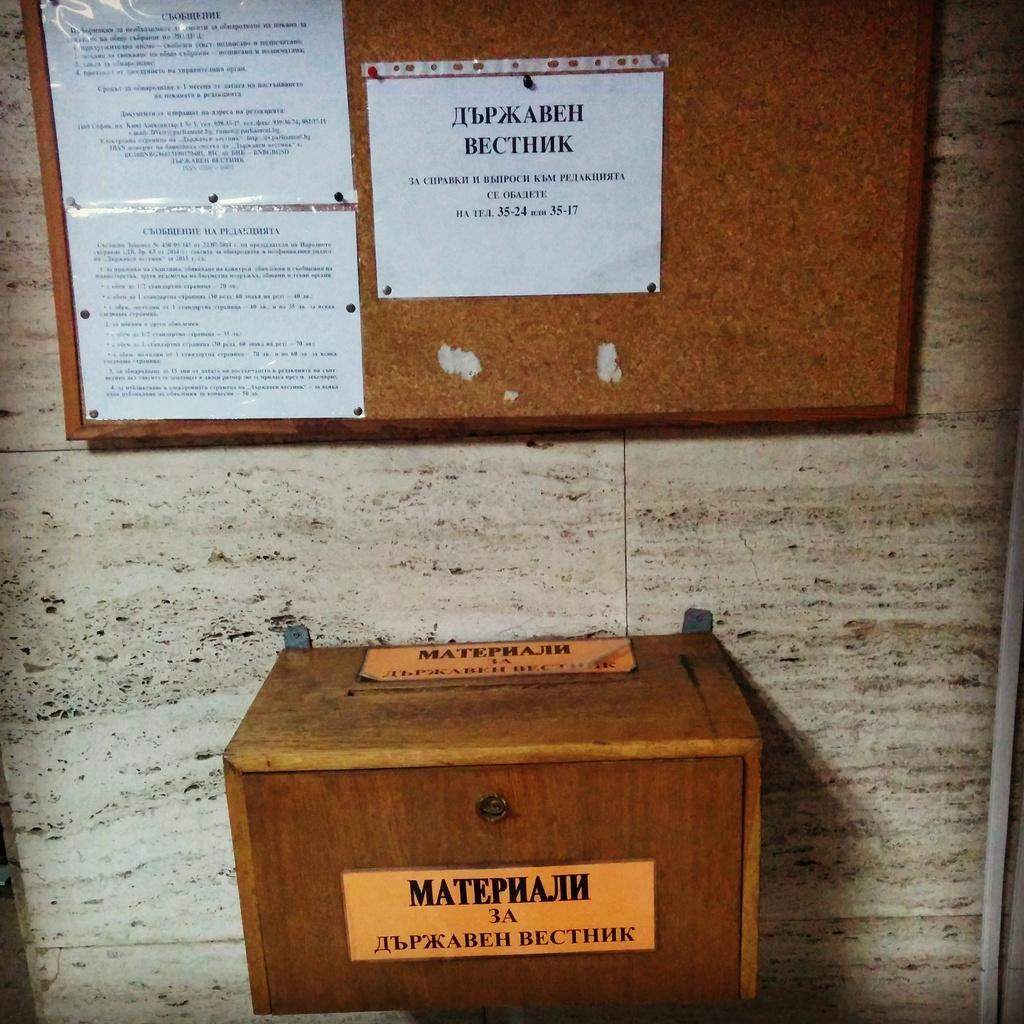<image>
Present a compact description of the photo's key features. A posted notice includes the number ranges 35-24 and 35-17. 